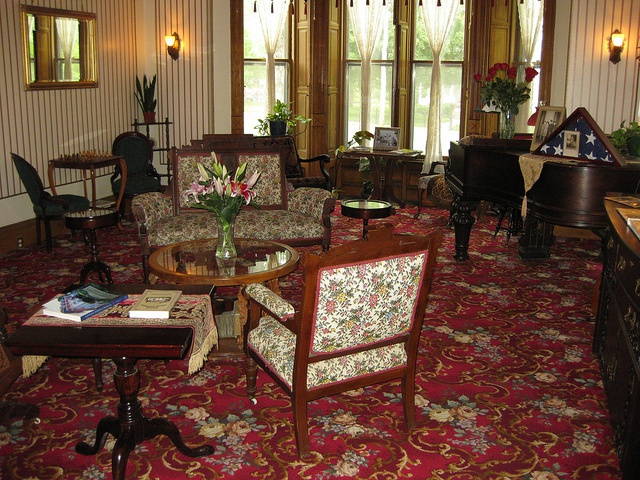Describe the objects in this image and their specific colors. I can see chair in olive, maroon, beige, and tan tones, couch in olive, gray, maroon, and black tones, chair in olive, black, gray, and darkgreen tones, chair in olive, black, maroon, gray, and darkgreen tones, and chair in olive, black, maroon, and gray tones in this image. 